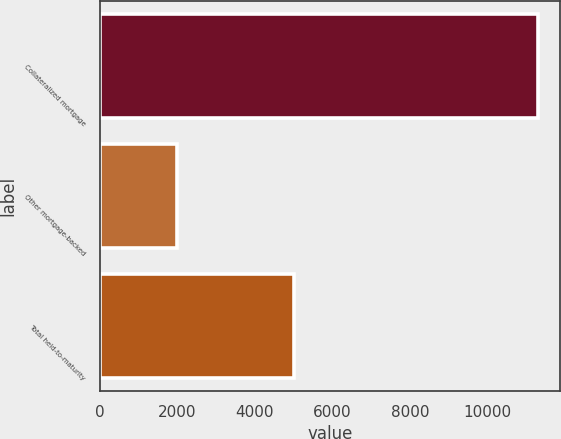<chart> <loc_0><loc_0><loc_500><loc_500><bar_chart><fcel>Collateralized mortgage<fcel>Other mortgage-backed<fcel>Total held-to-maturity<nl><fcel>11310<fcel>2004<fcel>5015<nl></chart> 